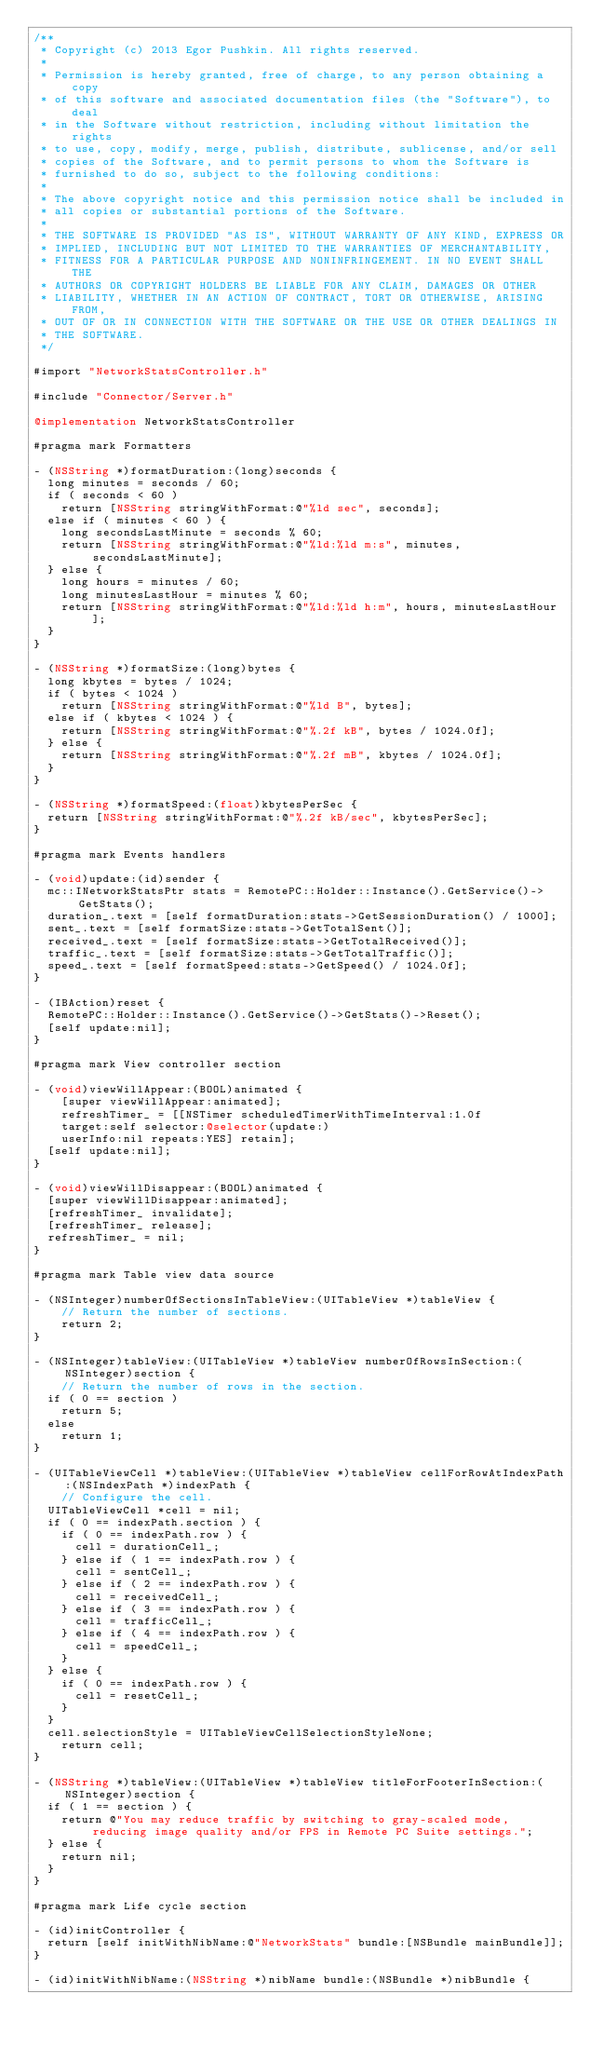<code> <loc_0><loc_0><loc_500><loc_500><_ObjectiveC_>/**
 * Copyright (c) 2013 Egor Pushkin. All rights reserved.
 * 
 * Permission is hereby granted, free of charge, to any person obtaining a copy
 * of this software and associated documentation files (the "Software"), to deal
 * in the Software without restriction, including without limitation the rights
 * to use, copy, modify, merge, publish, distribute, sublicense, and/or sell
 * copies of the Software, and to permit persons to whom the Software is
 * furnished to do so, subject to the following conditions:
 * 
 * The above copyright notice and this permission notice shall be included in
 * all copies or substantial portions of the Software.
 * 
 * THE SOFTWARE IS PROVIDED "AS IS", WITHOUT WARRANTY OF ANY KIND, EXPRESS OR
 * IMPLIED, INCLUDING BUT NOT LIMITED TO THE WARRANTIES OF MERCHANTABILITY,
 * FITNESS FOR A PARTICULAR PURPOSE AND NONINFRINGEMENT. IN NO EVENT SHALL THE
 * AUTHORS OR COPYRIGHT HOLDERS BE LIABLE FOR ANY CLAIM, DAMAGES OR OTHER
 * LIABILITY, WHETHER IN AN ACTION OF CONTRACT, TORT OR OTHERWISE, ARISING FROM,
 * OUT OF OR IN CONNECTION WITH THE SOFTWARE OR THE USE OR OTHER DEALINGS IN
 * THE SOFTWARE.
 */

#import "NetworkStatsController.h"

#include "Connector/Server.h"

@implementation NetworkStatsController

#pragma mark Formatters

- (NSString *)formatDuration:(long)seconds {
	long minutes = seconds / 60;
	if ( seconds < 60 )
		return [NSString stringWithFormat:@"%ld sec", seconds];
	else if ( minutes < 60 ) {
		long secondsLastMinute = seconds % 60;		
		return [NSString stringWithFormat:@"%ld:%ld m:s", minutes, secondsLastMinute];
	} else {
		long hours = minutes / 60;		
		long minutesLastHour = minutes % 60;		
		return [NSString stringWithFormat:@"%ld:%ld h:m", hours, minutesLastHour];
	}
}

- (NSString *)formatSize:(long)bytes {
	long kbytes = bytes / 1024;
	if ( bytes < 1024 )
		return [NSString stringWithFormat:@"%ld B", bytes];
	else if ( kbytes < 1024 ) {		
		return [NSString stringWithFormat:@"%.2f kB", bytes / 1024.0f];
	} else {
		return [NSString stringWithFormat:@"%.2f mB", kbytes / 1024.0f];		
	}
}

- (NSString *)formatSpeed:(float)kbytesPerSec {
	return [NSString stringWithFormat:@"%.2f kB/sec", kbytesPerSec];
}

#pragma mark Events handlers

- (void)update:(id)sender {
	mc::INetworkStatsPtr stats = RemotePC::Holder::Instance().GetService()->GetStats();
	duration_.text = [self formatDuration:stats->GetSessionDuration() / 1000];
	sent_.text = [self formatSize:stats->GetTotalSent()];
	received_.text = [self formatSize:stats->GetTotalReceived()];
	traffic_.text = [self formatSize:stats->GetTotalTraffic()];
	speed_.text = [self formatSpeed:stats->GetSpeed() / 1024.0f];
}

- (IBAction)reset {
	RemotePC::Holder::Instance().GetService()->GetStats()->Reset();
	[self update:nil]; 	
}

#pragma mark View controller section

- (void)viewWillAppear:(BOOL)animated {
    [super viewWillAppear:animated];
    refreshTimer_ = [[NSTimer scheduledTimerWithTimeInterval:1.0f
		target:self selector:@selector(update:)
		userInfo:nil repeats:YES] retain];
	[self update:nil];
}

- (void)viewWillDisappear:(BOOL)animated {
	[super viewWillDisappear:animated];
	[refreshTimer_ invalidate];
	[refreshTimer_ release];
	refreshTimer_ = nil;
}

#pragma mark Table view data source

- (NSInteger)numberOfSectionsInTableView:(UITableView *)tableView {
    // Return the number of sections.
    return 2;
}

- (NSInteger)tableView:(UITableView *)tableView numberOfRowsInSection:(NSInteger)section {
    // Return the number of rows in the section.
	if ( 0 == section )
		return 5;
	else
		return 1;
}

- (UITableViewCell *)tableView:(UITableView *)tableView cellForRowAtIndexPath:(NSIndexPath *)indexPath {
    // Configure the cell.
	UITableViewCell *cell = nil;
	if ( 0 == indexPath.section ) {
		if ( 0 == indexPath.row ) {
			cell = durationCell_;
		} else if ( 1 == indexPath.row ) { 
			cell = sentCell_;
		} else if ( 2 == indexPath.row ) { 
			cell = receivedCell_;
		} else if ( 3 == indexPath.row ) { 
			cell = trafficCell_;
		} else if ( 4 == indexPath.row ) { 
			cell = speedCell_;
		}
	} else {
		if ( 0 == indexPath.row ) {
			cell = resetCell_;
		} 
	}
	cell.selectionStyle = UITableViewCellSelectionStyleNone;
    return cell;
}

- (NSString *)tableView:(UITableView *)tableView titleForFooterInSection:(NSInteger)section {
	if ( 1 == section ) {
		return @"You may reduce traffic by switching to gray-scaled mode, reducing image quality and/or FPS in Remote PC Suite settings.";
	} else {
		return nil;
	}
}

#pragma mark Life cycle section

- (id)initController {
	return [self initWithNibName:@"NetworkStats" bundle:[NSBundle mainBundle]];
}

- (id)initWithNibName:(NSString *)nibName bundle:(NSBundle *)nibBundle {</code> 